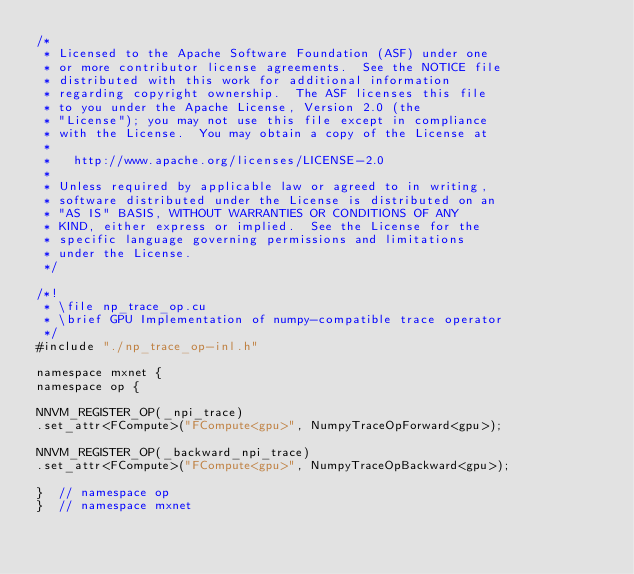Convert code to text. <code><loc_0><loc_0><loc_500><loc_500><_Cuda_>/*
 * Licensed to the Apache Software Foundation (ASF) under one
 * or more contributor license agreements.  See the NOTICE file
 * distributed with this work for additional information
 * regarding copyright ownership.  The ASF licenses this file
 * to you under the Apache License, Version 2.0 (the
 * "License"); you may not use this file except in compliance
 * with the License.  You may obtain a copy of the License at
 *
 *   http://www.apache.org/licenses/LICENSE-2.0
 *
 * Unless required by applicable law or agreed to in writing,
 * software distributed under the License is distributed on an
 * "AS IS" BASIS, WITHOUT WARRANTIES OR CONDITIONS OF ANY
 * KIND, either express or implied.  See the License for the
 * specific language governing permissions and limitations
 * under the License.
 */

/*!
 * \file np_trace_op.cu
 * \brief GPU Implementation of numpy-compatible trace operator
 */
#include "./np_trace_op-inl.h"

namespace mxnet {
namespace op {

NNVM_REGISTER_OP(_npi_trace)
.set_attr<FCompute>("FCompute<gpu>", NumpyTraceOpForward<gpu>);

NNVM_REGISTER_OP(_backward_npi_trace)
.set_attr<FCompute>("FCompute<gpu>", NumpyTraceOpBackward<gpu>);

}  // namespace op
}  // namespace mxnet
</code> 